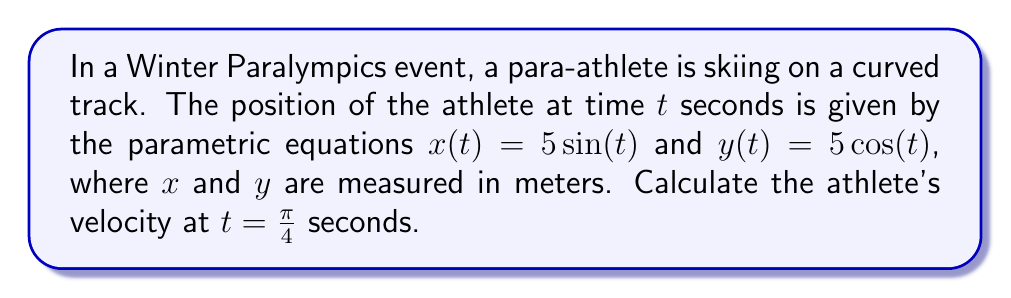Can you solve this math problem? To solve this problem, we need to use parametric equations and vector calculus. Let's break it down step by step:

1) The velocity vector $\vec{v}(t)$ is given by the derivative of the position vector with respect to time:

   $$\vec{v}(t) = \frac{d\vec{r}}{dt} = \left(\frac{dx}{dt}, \frac{dy}{dt}\right)$$

2) Let's calculate these derivatives:

   $$\frac{dx}{dt} = 5\cos(t)$$
   $$\frac{dy}{dt} = -5\sin(t)$$

3) Therefore, the velocity vector is:

   $$\vec{v}(t) = (5\cos(t), -5\sin(t))$$

4) At $t = \frac{\pi}{4}$, we have:

   $$\vec{v}(\frac{\pi}{4}) = (5\cos(\frac{\pi}{4}), -5\sin(\frac{\pi}{4}))$$

5) Recall that $\cos(\frac{\pi}{4}) = \sin(\frac{\pi}{4}) = \frac{\sqrt{2}}{2}$:

   $$\vec{v}(\frac{\pi}{4}) = (5\cdot\frac{\sqrt{2}}{2}, -5\cdot\frac{\sqrt{2}}{2}) = (\frac{5\sqrt{2}}{2}, -\frac{5\sqrt{2}}{2})$$

6) The magnitude of this velocity vector gives us the speed:

   $$|\vec{v}(\frac{\pi}{4})| = \sqrt{(\frac{5\sqrt{2}}{2})^2 + (-\frac{5\sqrt{2}}{2})^2}$$

7) Simplify:
   
   $$|\vec{v}(\frac{\pi}{4})| = \sqrt{2(\frac{5\sqrt{2}}{2})^2} = \sqrt{2\cdot\frac{50}{2}} = \sqrt{50} = 5\sqrt{2}$$

Therefore, the velocity of the athlete at $t = \frac{\pi}{4}$ seconds is $(5\sqrt{2}/2, -5\sqrt{2}/2)$ m/s, with a speed of $5\sqrt{2}$ m/s.
Answer: The athlete's velocity at $t = \frac{\pi}{4}$ seconds is $(5\sqrt{2}/2, -5\sqrt{2}/2)$ m/s, with a speed of $5\sqrt{2}$ m/s. 